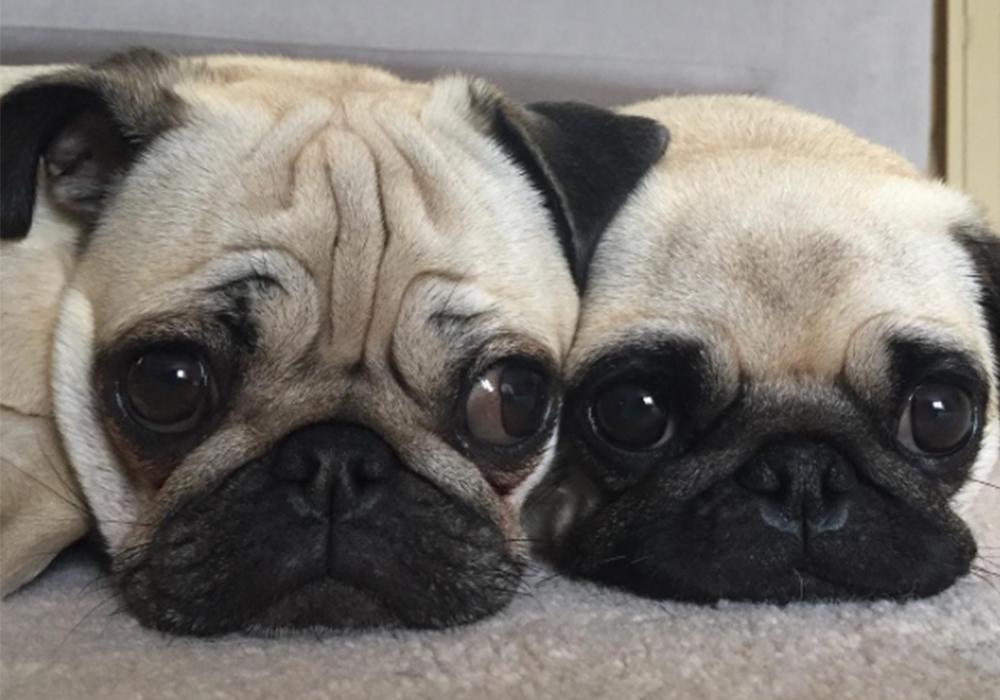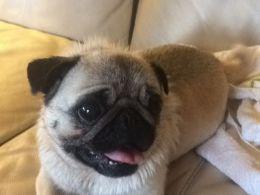The first image is the image on the left, the second image is the image on the right. Given the left and right images, does the statement "Each image in the pair has two pugs touching each other." hold true? Answer yes or no. No. The first image is the image on the left, the second image is the image on the right. Assess this claim about the two images: "There is exactly one pug in at least one image.". Correct or not? Answer yes or no. Yes. 